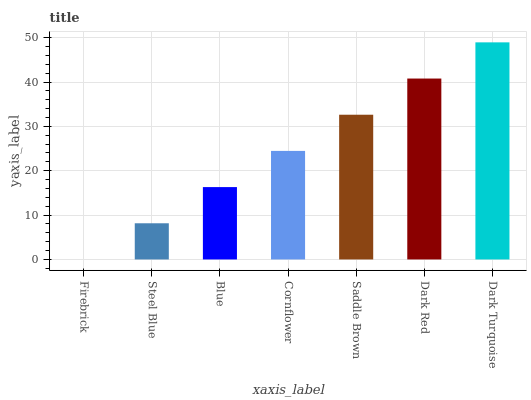Is Firebrick the minimum?
Answer yes or no. Yes. Is Dark Turquoise the maximum?
Answer yes or no. Yes. Is Steel Blue the minimum?
Answer yes or no. No. Is Steel Blue the maximum?
Answer yes or no. No. Is Steel Blue greater than Firebrick?
Answer yes or no. Yes. Is Firebrick less than Steel Blue?
Answer yes or no. Yes. Is Firebrick greater than Steel Blue?
Answer yes or no. No. Is Steel Blue less than Firebrick?
Answer yes or no. No. Is Cornflower the high median?
Answer yes or no. Yes. Is Cornflower the low median?
Answer yes or no. Yes. Is Dark Turquoise the high median?
Answer yes or no. No. Is Dark Red the low median?
Answer yes or no. No. 